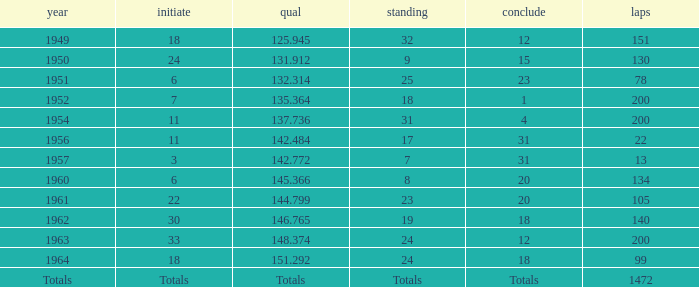Name the rank with finish of 12 and year of 1963 24.0. 